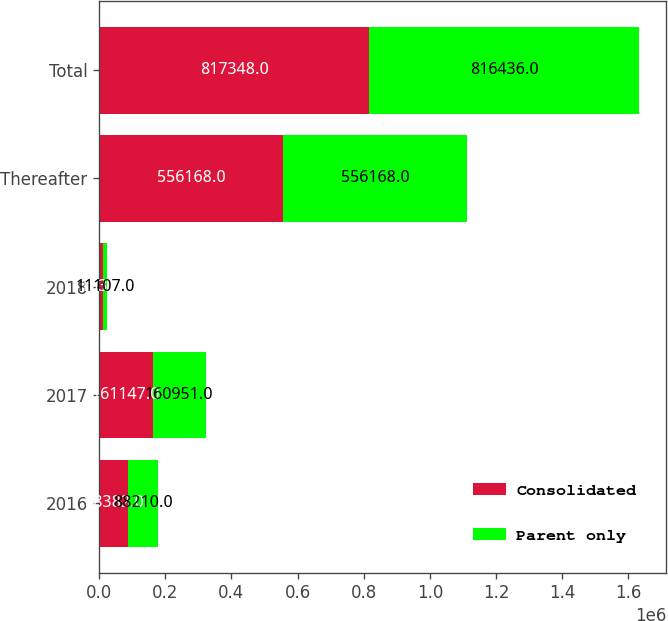Convert chart to OTSL. <chart><loc_0><loc_0><loc_500><loc_500><stacked_bar_chart><ecel><fcel>2016<fcel>2017<fcel>2018<fcel>Thereafter<fcel>Total<nl><fcel>Consolidated<fcel>88382<fcel>161147<fcel>11332<fcel>556168<fcel>817348<nl><fcel>Parent only<fcel>88210<fcel>160951<fcel>11107<fcel>556168<fcel>816436<nl></chart> 